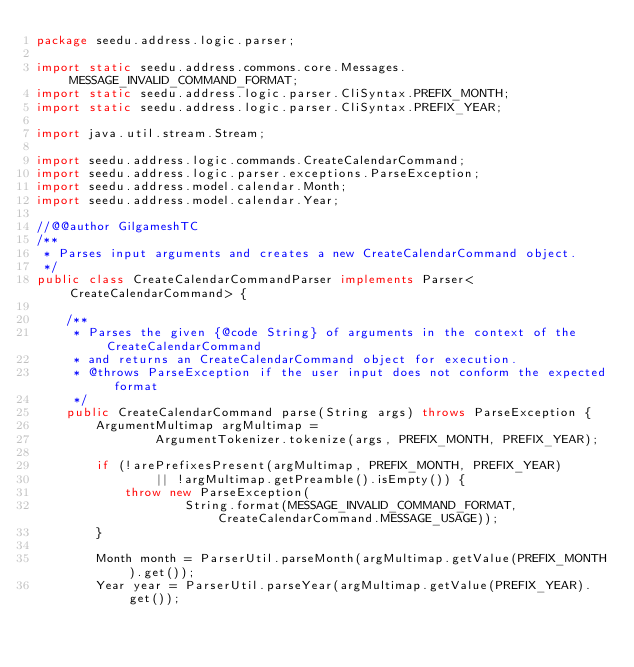Convert code to text. <code><loc_0><loc_0><loc_500><loc_500><_Java_>package seedu.address.logic.parser;

import static seedu.address.commons.core.Messages.MESSAGE_INVALID_COMMAND_FORMAT;
import static seedu.address.logic.parser.CliSyntax.PREFIX_MONTH;
import static seedu.address.logic.parser.CliSyntax.PREFIX_YEAR;

import java.util.stream.Stream;

import seedu.address.logic.commands.CreateCalendarCommand;
import seedu.address.logic.parser.exceptions.ParseException;
import seedu.address.model.calendar.Month;
import seedu.address.model.calendar.Year;

//@@author GilgameshTC
/**
 * Parses input arguments and creates a new CreateCalendarCommand object.
 */
public class CreateCalendarCommandParser implements Parser<CreateCalendarCommand> {

    /**
     * Parses the given {@code String} of arguments in the context of the CreateCalendarCommand
     * and returns an CreateCalendarCommand object for execution.
     * @throws ParseException if the user input does not conform the expected format
     */
    public CreateCalendarCommand parse(String args) throws ParseException {
        ArgumentMultimap argMultimap =
                ArgumentTokenizer.tokenize(args, PREFIX_MONTH, PREFIX_YEAR);

        if (!arePrefixesPresent(argMultimap, PREFIX_MONTH, PREFIX_YEAR)
                || !argMultimap.getPreamble().isEmpty()) {
            throw new ParseException(
                    String.format(MESSAGE_INVALID_COMMAND_FORMAT, CreateCalendarCommand.MESSAGE_USAGE));
        }

        Month month = ParserUtil.parseMonth(argMultimap.getValue(PREFIX_MONTH).get());
        Year year = ParserUtil.parseYear(argMultimap.getValue(PREFIX_YEAR).get());
</code> 